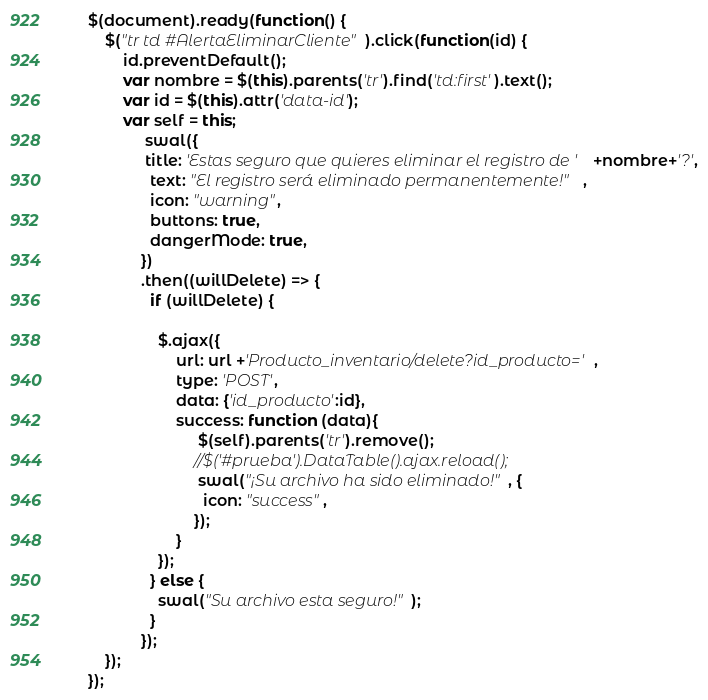Convert code to text. <code><loc_0><loc_0><loc_500><loc_500><_JavaScript_>
	$(document).ready(function() {
		$("tr td #AlertaEliminarCliente").click(function(id) {
			id.preventDefault();
			var nombre = $(this).parents('tr').find('td:first').text();
			var id = $(this).attr('data-id');
			var self = this;
				 swal({
				 title: 'Estas seguro que quieres eliminar el registro de '+nombre+'?',
				  text: "El registro será eliminado permanentemente!",
				  icon: "warning",
				  buttons: true,
				  dangerMode: true,
				})
				.then((willDelete) => {
				  if (willDelete) {
				   
					$.ajax({
						url: url +'Producto_inventario/delete?id_producto=',
						type: 'POST',
						data: {'id_producto':id},
						success: function (data){
							 $(self).parents('tr').remove();
							//$('#prueba').DataTable().ajax.reload();
							 swal("¡Su archivo ha sido eliminado!", {
						      icon: "success",
						    });	  
						}	
					});
				  } else {
				    swal("Su archivo esta seguro!");
				  }
				});
		});	
	});</code> 